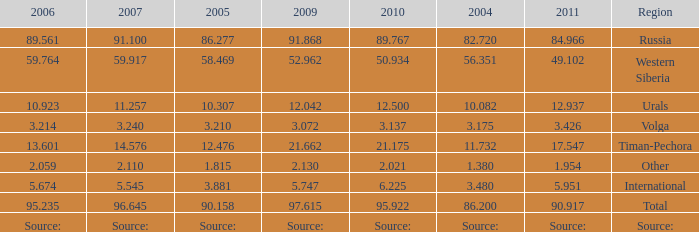What is the 2007 Lukoil oil prodroduction when in 2010 oil production 3.137 million tonnes? 3.24. 